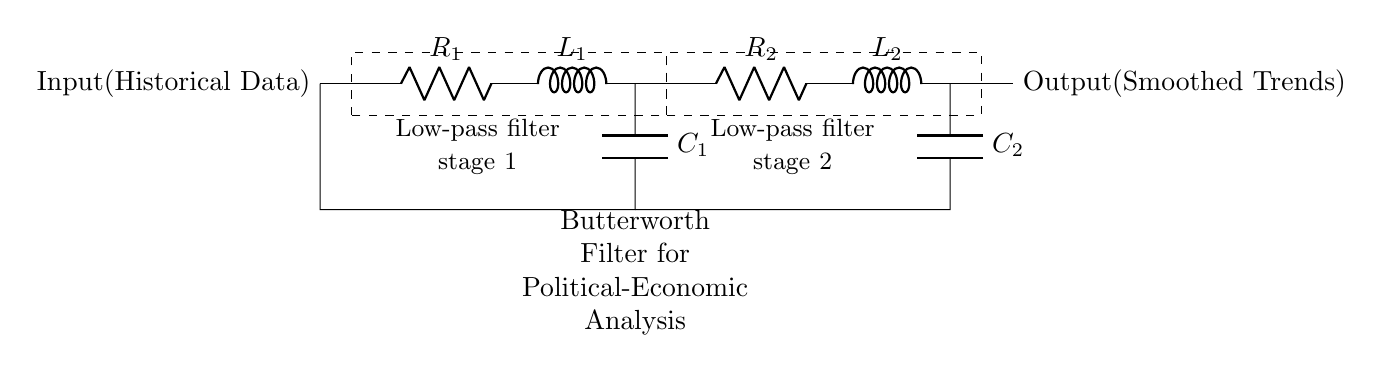What are the main components of the filter? The main components are resistors, inductors, and capacitors, which are used to create the low-pass filter stages.
Answer: resistors, inductors, capacitors What is the function of the first stage in the filter? The first stage is a low-pass filter designed to allow low-frequency signals and attenuate high-frequency noise from historical data.
Answer: low-pass filter How many stages are present in this Butterworth filter? There are two stages in this Butterworth filter indicated by the two separate filter sections in the diagram.
Answer: two What is the output of this circuit? The output is the smoothed trends derived from the historical data after passing through the filter.
Answer: smoothed trends What kind of filter is represented in this circuit? The circuit represents a Butterworth filter, known for its flat frequency response in the passband.
Answer: Butterworth filter What is the purpose of using a Butterworth filter in this context? The purpose is to improve the accuracy of analysis by smoothing out fluctuations in historical economic trends and political influences.
Answer: smoothing trends What does the text indicate about the analysis purpose? The text indicates that the filter is used for political-economic analysis, aiming to derive insights from complex data.
Answer: political-economic analysis 